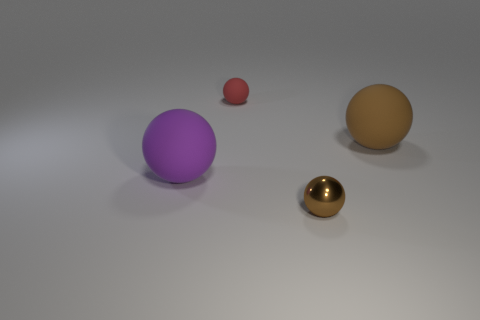Subtract all large brown rubber balls. How many balls are left? 3 Add 3 brown rubber objects. How many objects exist? 7 Subtract all brown balls. How many balls are left? 2 Subtract 3 spheres. How many spheres are left? 1 Subtract all red blocks. How many yellow spheres are left? 0 Subtract all metallic objects. Subtract all small purple matte cylinders. How many objects are left? 3 Add 3 metallic objects. How many metallic objects are left? 4 Add 3 metal balls. How many metal balls exist? 4 Subtract 0 gray cylinders. How many objects are left? 4 Subtract all yellow balls. Subtract all green cubes. How many balls are left? 4 